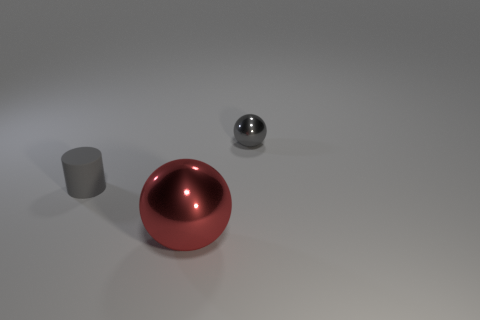Is there a red metallic ball?
Ensure brevity in your answer.  Yes. Is the number of balls in front of the cylinder greater than the number of small things that are in front of the big metal object?
Make the answer very short. Yes. What is the material of the small gray thing that is the same shape as the big object?
Offer a terse response. Metal. Are there any other things that have the same size as the red thing?
Keep it short and to the point. No. Do the thing behind the matte cylinder and the small thing in front of the small gray metallic object have the same color?
Give a very brief answer. Yes. What shape is the small gray rubber thing?
Your response must be concise. Cylinder. Is the number of shiny objects behind the rubber thing greater than the number of tiny metal cylinders?
Your answer should be compact. Yes. The small object left of the large red ball has what shape?
Offer a terse response. Cylinder. How many other objects are there of the same shape as the large object?
Make the answer very short. 1. Are the gray thing that is right of the tiny gray rubber cylinder and the red sphere made of the same material?
Keep it short and to the point. Yes. 